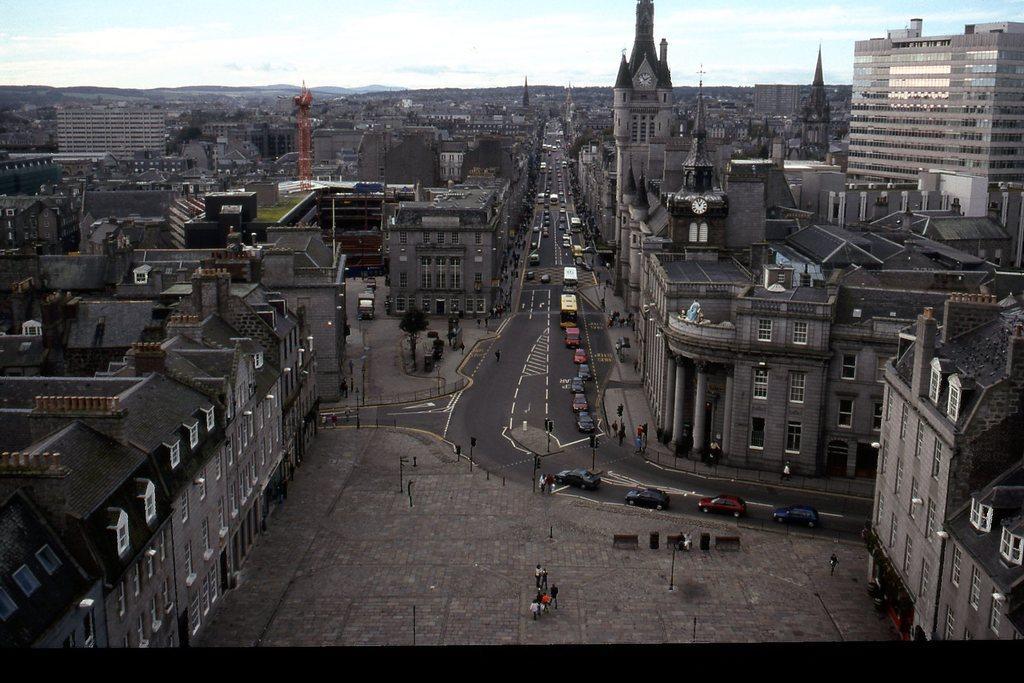Can you describe this image briefly? This image is taken outdoors. At the top of the image there is the sky with clouds. At the bottom of the image there is a floor. In the middle of the image there are many buildings with walls, windows, doors, pillars and roofs. There are a few towers with clocks. There is an iron bar and there are many poles. Many people are walking on a road a few are standing. Many vehicles are moving on the road and a few are parked on the road. 